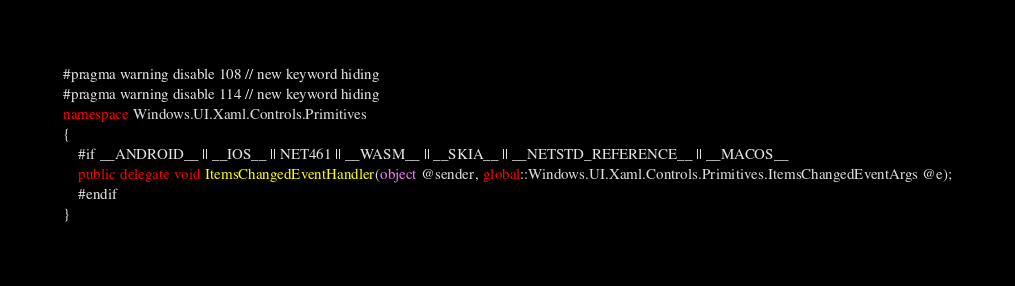Convert code to text. <code><loc_0><loc_0><loc_500><loc_500><_C#_>#pragma warning disable 108 // new keyword hiding
#pragma warning disable 114 // new keyword hiding
namespace Windows.UI.Xaml.Controls.Primitives
{
	#if __ANDROID__ || __IOS__ || NET461 || __WASM__ || __SKIA__ || __NETSTD_REFERENCE__ || __MACOS__
	public delegate void ItemsChangedEventHandler(object @sender, global::Windows.UI.Xaml.Controls.Primitives.ItemsChangedEventArgs @e);
	#endif
}
</code> 